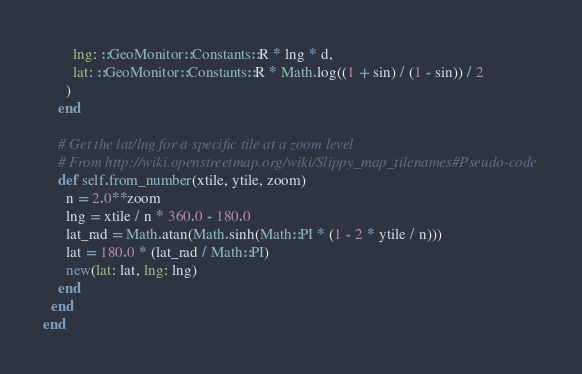Convert code to text. <code><loc_0><loc_0><loc_500><loc_500><_Ruby_>        lng: ::GeoMonitor::Constants::R * lng * d,
        lat: ::GeoMonitor::Constants::R * Math.log((1 + sin) / (1 - sin)) / 2
      )
    end

    # Get the lat/lng for a specific tile at a zoom level
    # From http://wiki.openstreetmap.org/wiki/Slippy_map_tilenames#Pseudo-code
    def self.from_number(xtile, ytile, zoom)
      n = 2.0**zoom
      lng = xtile / n * 360.0 - 180.0
      lat_rad = Math.atan(Math.sinh(Math::PI * (1 - 2 * ytile / n)))
      lat = 180.0 * (lat_rad / Math::PI)
      new(lat: lat, lng: lng)
    end
  end
end
</code> 